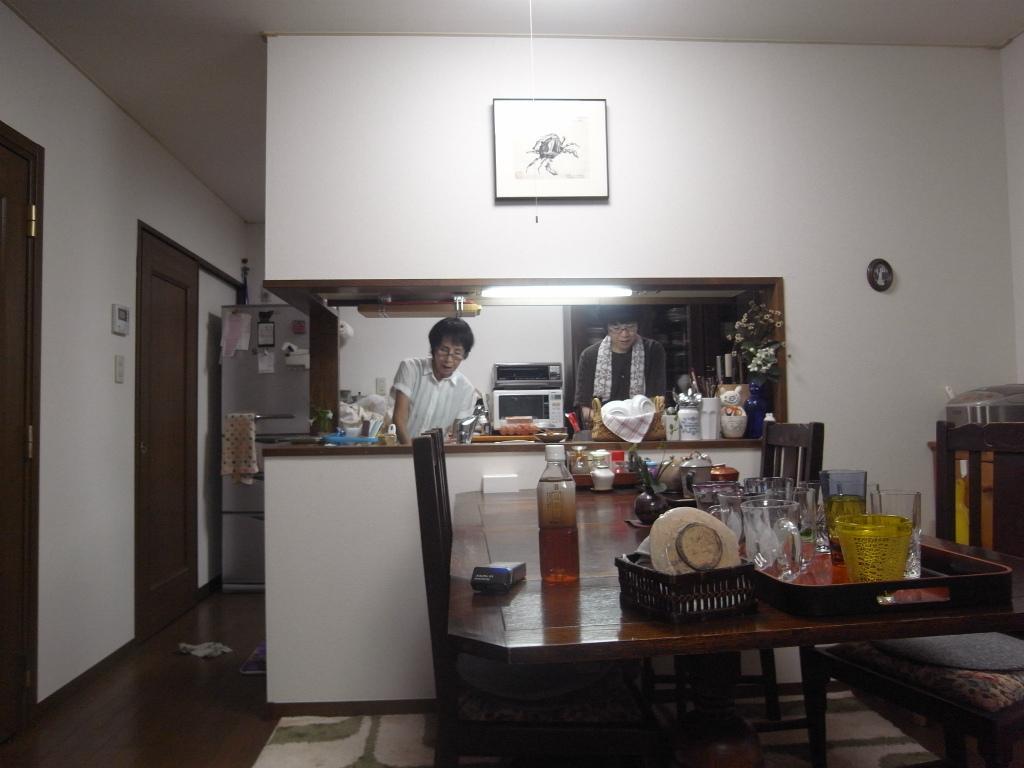Could you give a brief overview of what you see in this image? In the foreground of this image, there are glasses, a basket, a bottle and few more objects on the table. We can also see chairs around it. At the bottom, there is a mat and the floor. At the top, there is a frame on the wall. In the background, there are two persons standing and a flower vase, containers and few more objects on the desk, doors, wall, refrigerator, microwave oven and a light. 